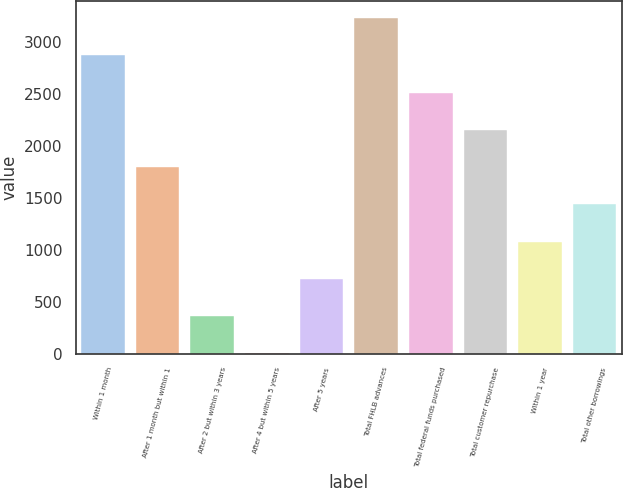Convert chart. <chart><loc_0><loc_0><loc_500><loc_500><bar_chart><fcel>Within 1 month<fcel>After 1 month but within 1<fcel>After 2 but within 3 years<fcel>After 4 but within 5 years<fcel>After 5 years<fcel>Total FHLB advances<fcel>Total federal funds purchased<fcel>Total customer repurchase<fcel>Within 1 year<fcel>Total other borrowings<nl><fcel>2874.84<fcel>1797<fcel>359.88<fcel>0.6<fcel>719.16<fcel>3234.12<fcel>2515.56<fcel>2156.28<fcel>1078.44<fcel>1437.72<nl></chart> 